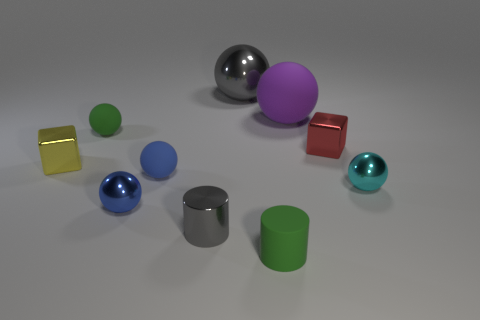Subtract 3 balls. How many balls are left? 3 Subtract all small green spheres. How many spheres are left? 5 Subtract all green balls. How many balls are left? 5 Subtract all brown spheres. Subtract all gray blocks. How many spheres are left? 6 Subtract all spheres. How many objects are left? 4 Add 5 small green rubber cubes. How many small green rubber cubes exist? 5 Subtract 0 brown spheres. How many objects are left? 10 Subtract all small rubber cylinders. Subtract all small green matte spheres. How many objects are left? 8 Add 1 tiny green spheres. How many tiny green spheres are left? 2 